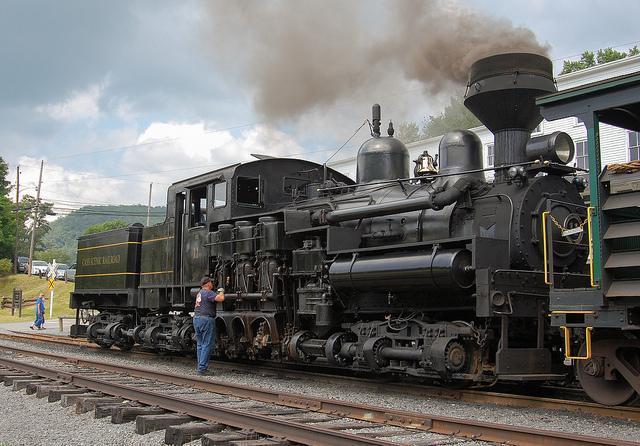How many people near the tracks?
Give a very brief answer. 2. How many people are by the train?
Give a very brief answer. 2. 